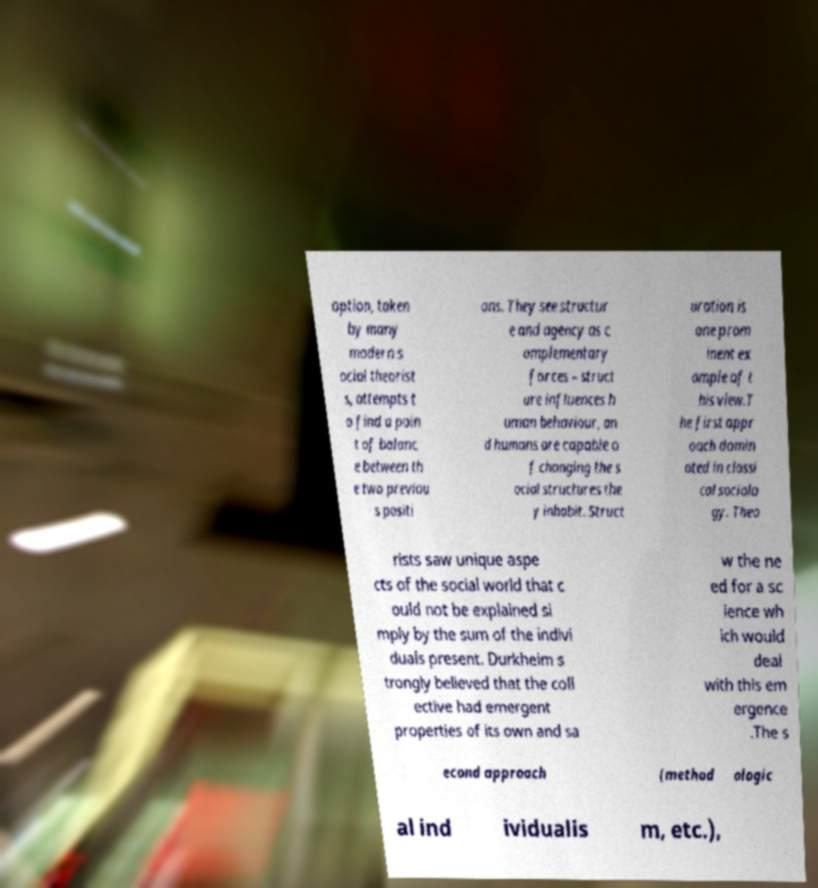Please read and relay the text visible in this image. What does it say? option, taken by many modern s ocial theorist s, attempts t o find a poin t of balanc e between th e two previou s positi ons. They see structur e and agency as c omplementary forces – struct ure influences h uman behaviour, an d humans are capable o f changing the s ocial structures the y inhabit. Struct uration is one prom inent ex ample of t his view.T he first appr oach domin ated in classi cal sociolo gy. Theo rists saw unique aspe cts of the social world that c ould not be explained si mply by the sum of the indivi duals present. Durkheim s trongly believed that the coll ective had emergent properties of its own and sa w the ne ed for a sc ience wh ich would deal with this em ergence .The s econd approach (method ologic al ind ividualis m, etc.), 